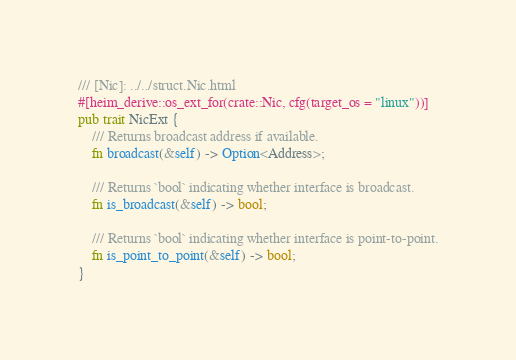<code> <loc_0><loc_0><loc_500><loc_500><_Rust_>/// [Nic]: ../../struct.Nic.html
#[heim_derive::os_ext_for(crate::Nic, cfg(target_os = "linux"))]
pub trait NicExt {
    /// Returns broadcast address if available.
    fn broadcast(&self) -> Option<Address>;

    /// Returns `bool` indicating whether interface is broadcast.
    fn is_broadcast(&self) -> bool;

    /// Returns `bool` indicating whether interface is point-to-point.
    fn is_point_to_point(&self) -> bool;
}
</code> 